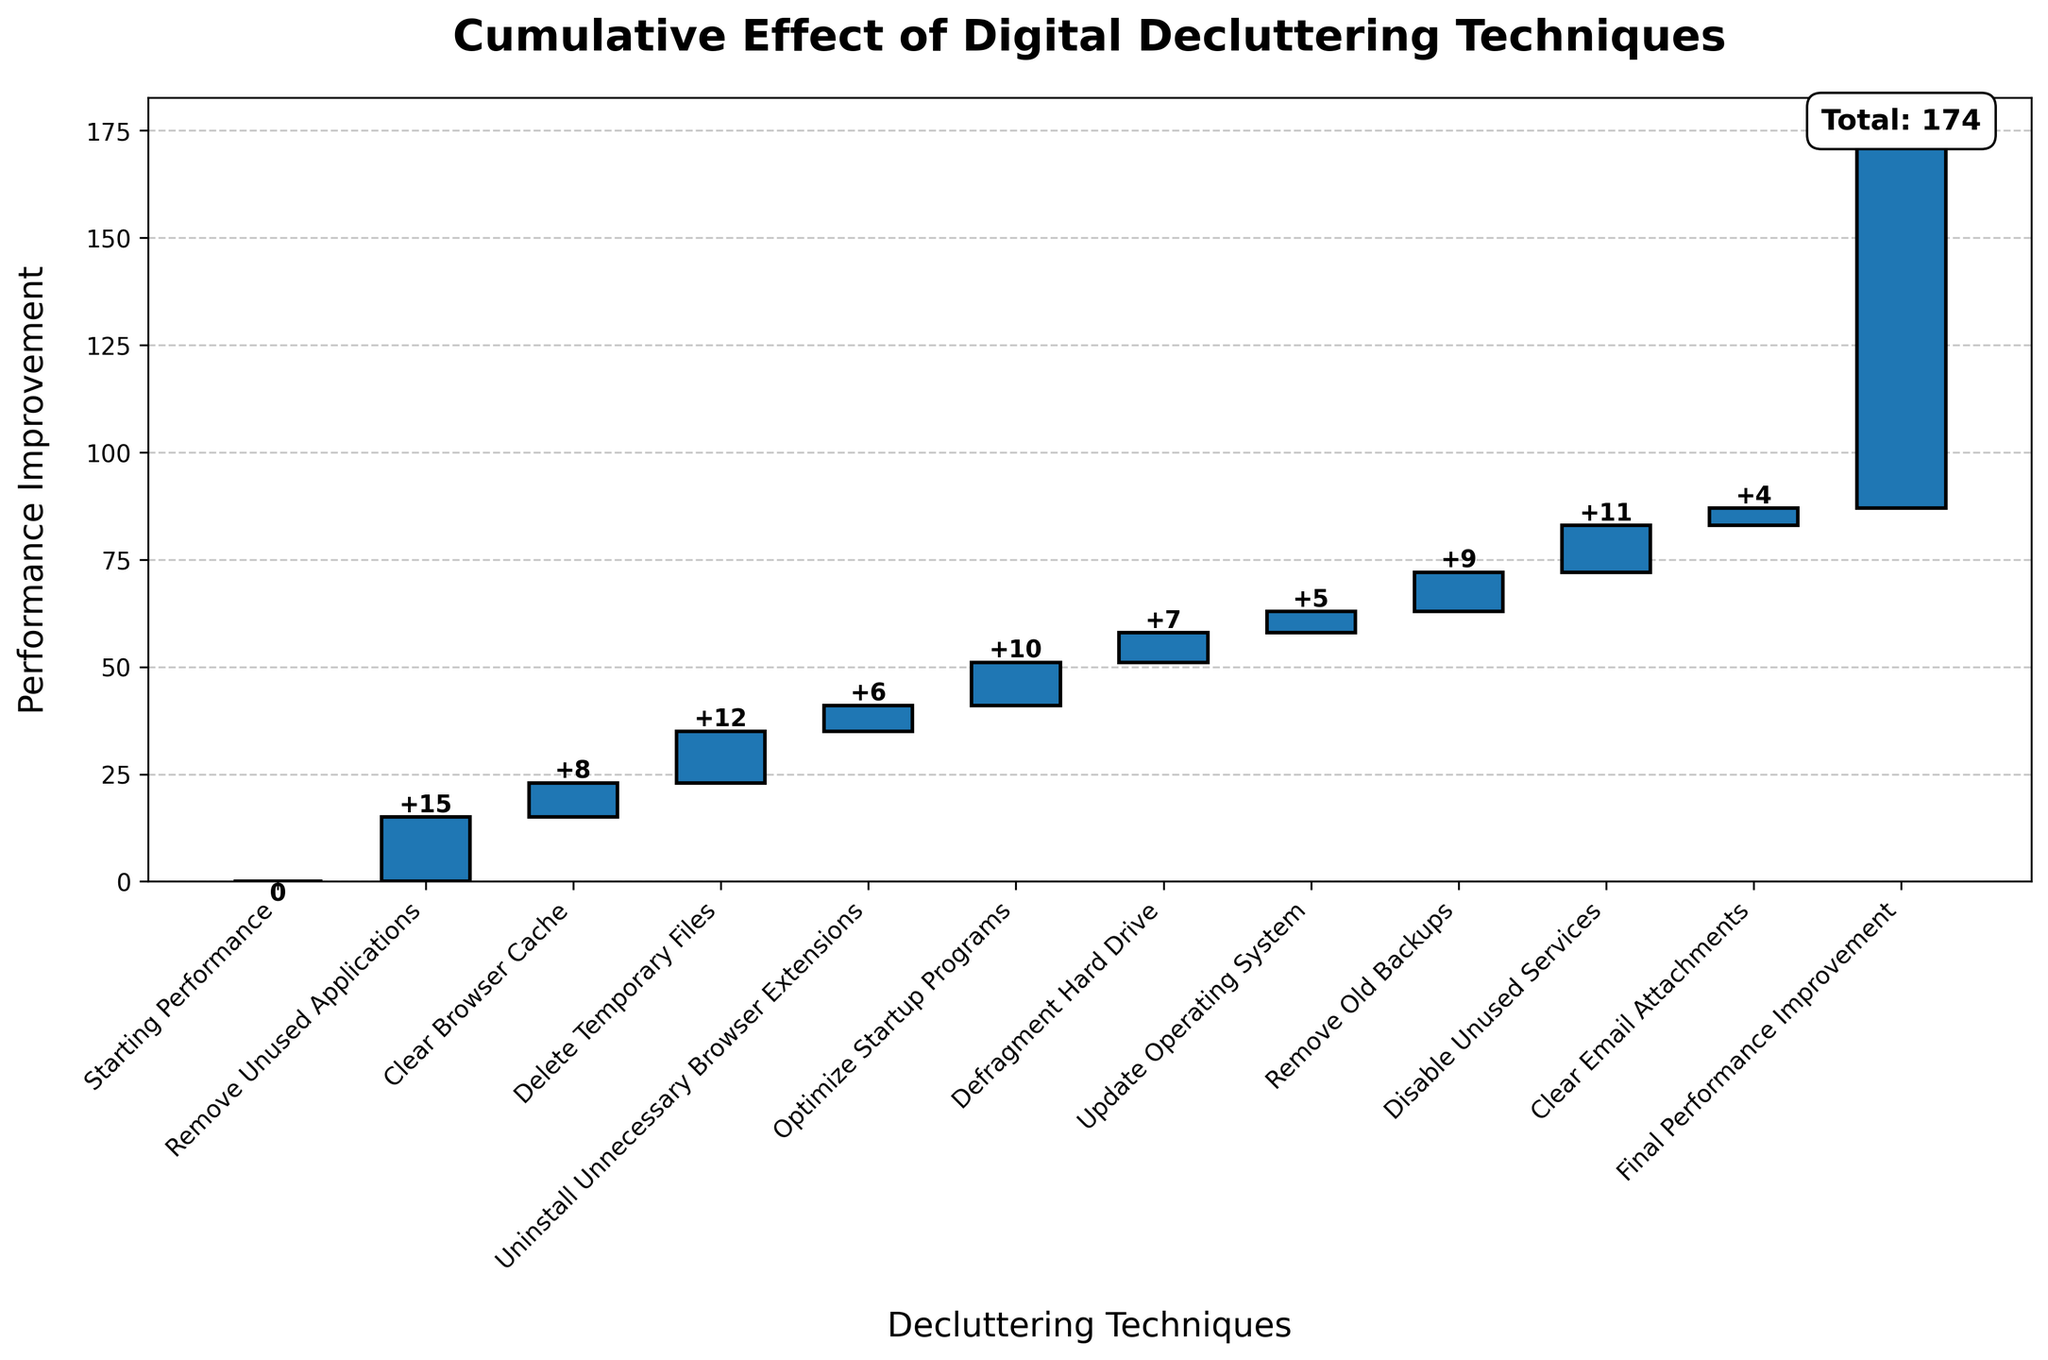What is the title of the chart? The title is usually found at the top of the chart. Here, the title printed at the top is "Cumulative Effect of Digital Decluttering Techniques".
Answer: Cumulative Effect of Digital Decluttering Techniques What is the total performance improvement achieved? The total performance improvement is found at the end of the cumulative values and is often labeled or highlighted. Here, it is labeled explicitly as "Total: 87".
Answer: 87 Which decluttering technique has the smallest impact on performance? By looking at the individual bar heights and corresponding value labels, the smallest impact is from the "Clear Email Attachments" technique with a value of 4.
Answer: Clear Email Attachments How much performance improvement is gained from removing unused applications and clearing the browser cache combined? To find the combined improvement, sum up the values for "Remove Unused Applications" (15) and "Clear Browser Cache" (8), which is 15 + 8.
Answer: 23 Which technique resulted in a performance improvement that is exactly half of the final performance improvement? First, find half of the final performance improvement, which is 87/2 = 43.5. None of the individual techniques have this value, so there is no such technique.
Answer: None What is the cumulative performance improvement after deleting temporary files? Look at the cumulative value right after the "Delete Temporary Files" bar. Adding up values for "Remove Unused Applications" (15), "Clear Browser Cache" (8), and "Delete Temporary Files" (12) gives 15 + 8 + 12 = 35.
Answer: 35 Which technique has a higher performance improvement, uninstalling unnecessary browser extensions or defragmenting the hard drive? Compare the values provided for both techniques: "Uninstall Unnecessary Browser Extensions" (6) and "Defragment Hard Drive" (7). The latter is higher.
Answer: Defragment Hard Drive How many decluttering techniques improved the performance by 10 or more units? Count the bars that have values of 10 or more: "Remove Unused Applications" (15), "Delete Temporary Files" (12), "Optimize Startup Programs" (10), and "Disable Unused Services" (11) - making a total of 4 techniques.
Answer: 4 What is the total cumulative performance improvement after optimizing startup programs? Sum the values of all steps up to and including "Optimize Startup Programs": 15 (Remove Unused Applications) + 8 (Clear Browser Cache) + 12 (Delete Temporary Files) + 6 (Uninstall Unnecessary Browser Extensions) + 10 (Optimize Startup Programs) which equates to 51.
Answer: 51 